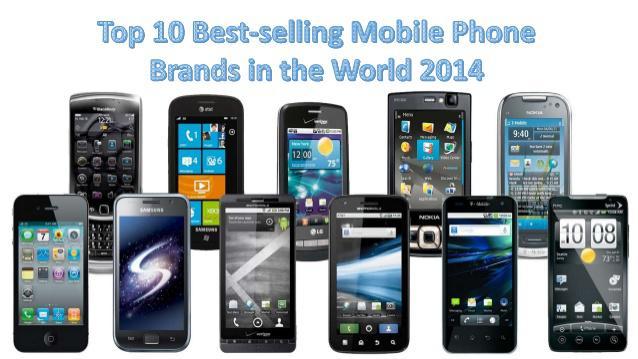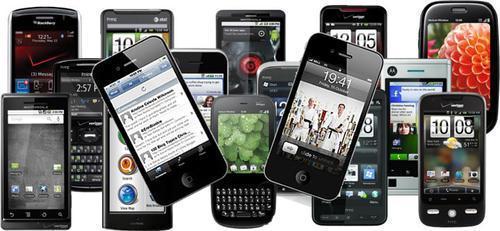The first image is the image on the left, the second image is the image on the right. Evaluate the accuracy of this statement regarding the images: "One image contains multiple devices with none overlapping, and the other image contains multiple devices with at least some overlapping.". Is it true? Answer yes or no. No. 